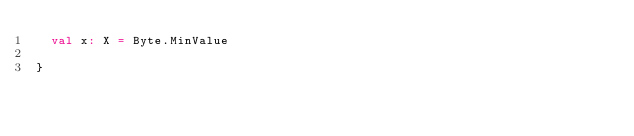<code> <loc_0><loc_0><loc_500><loc_500><_Scala_>  val x: X = Byte.MinValue

}
</code> 